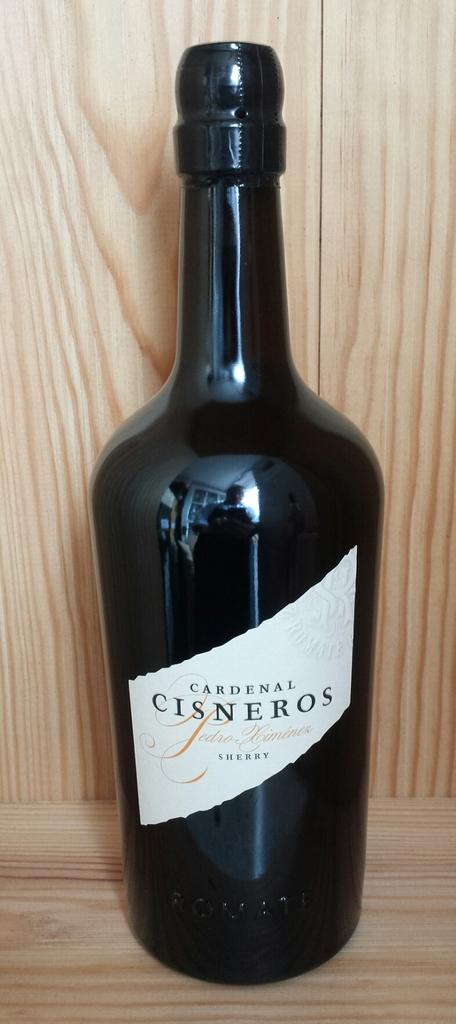<image>
Summarize the visual content of the image. The bottle of Sherry is made by  Cardenal Cisneros. 